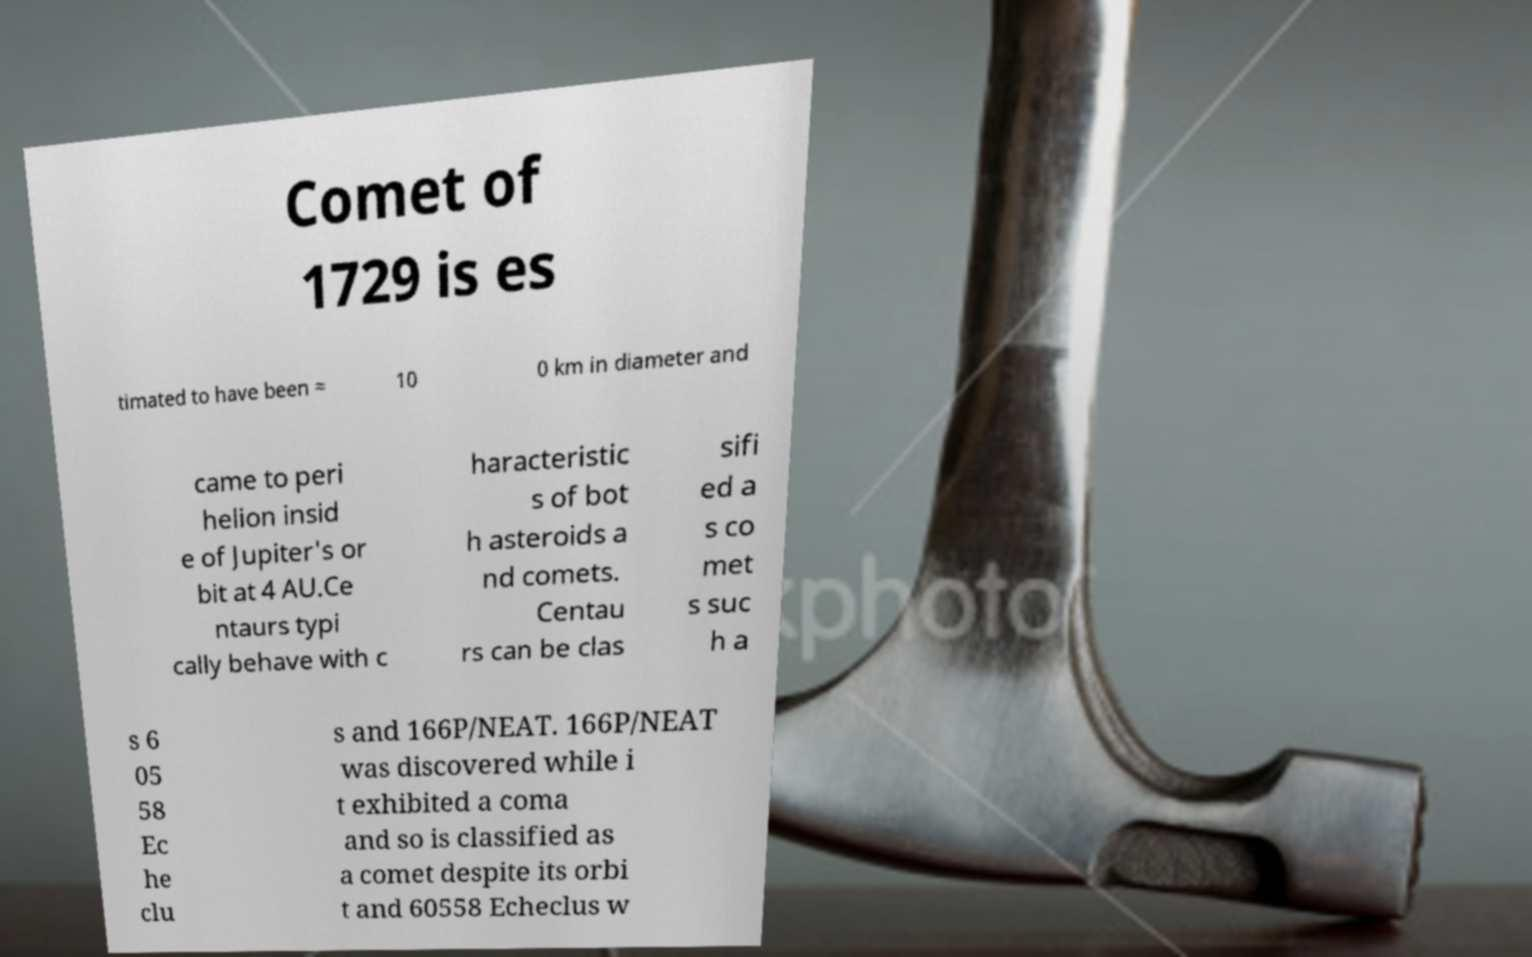There's text embedded in this image that I need extracted. Can you transcribe it verbatim? Comet of 1729 is es timated to have been ≈ 10 0 km in diameter and came to peri helion insid e of Jupiter's or bit at 4 AU.Ce ntaurs typi cally behave with c haracteristic s of bot h asteroids a nd comets. Centau rs can be clas sifi ed a s co met s suc h a s 6 05 58 Ec he clu s and 166P/NEAT. 166P/NEAT was discovered while i t exhibited a coma and so is classified as a comet despite its orbi t and 60558 Echeclus w 